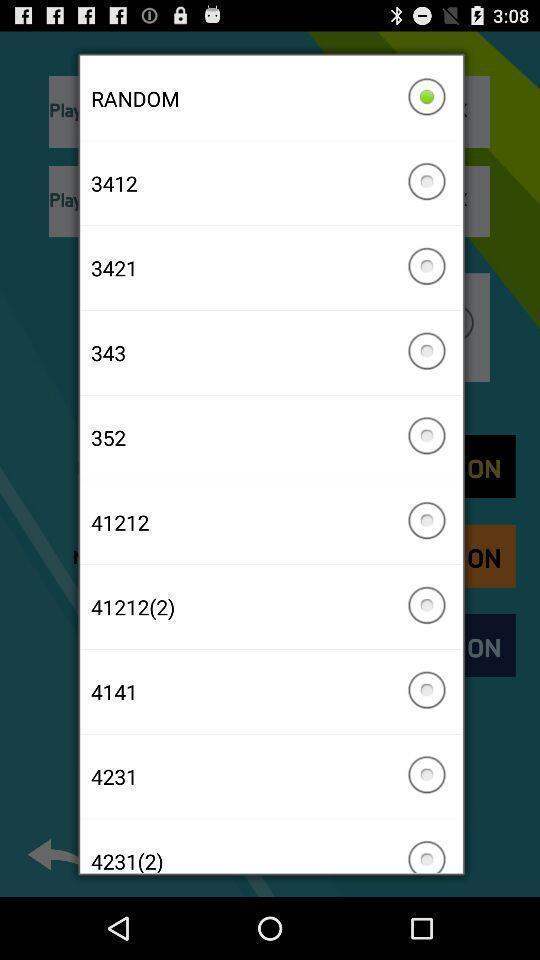Describe this image in words. Screen shows list of random numbers. 